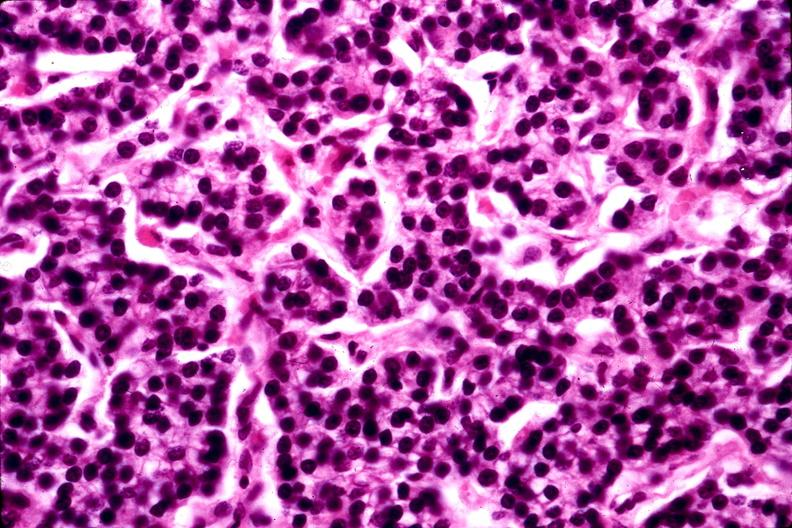what does this image show?
Answer the question using a single word or phrase. Parathyroid adenoma 